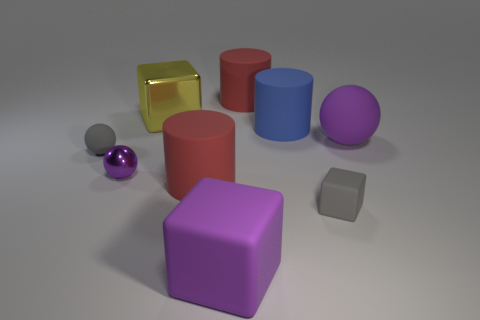Subtract all large purple matte blocks. How many blocks are left? 2 Add 1 yellow things. How many objects exist? 10 Subtract all purple blocks. How many blocks are left? 2 Subtract 1 balls. How many balls are left? 2 Subtract 0 brown blocks. How many objects are left? 9 Subtract all red cylinders. Subtract all purple cubes. How many cylinders are left? 1 Subtract all blue cylinders. How many gray cubes are left? 1 Subtract all small gray balls. Subtract all small purple metal spheres. How many objects are left? 7 Add 1 large cylinders. How many large cylinders are left? 4 Add 2 large purple rubber things. How many large purple rubber things exist? 4 